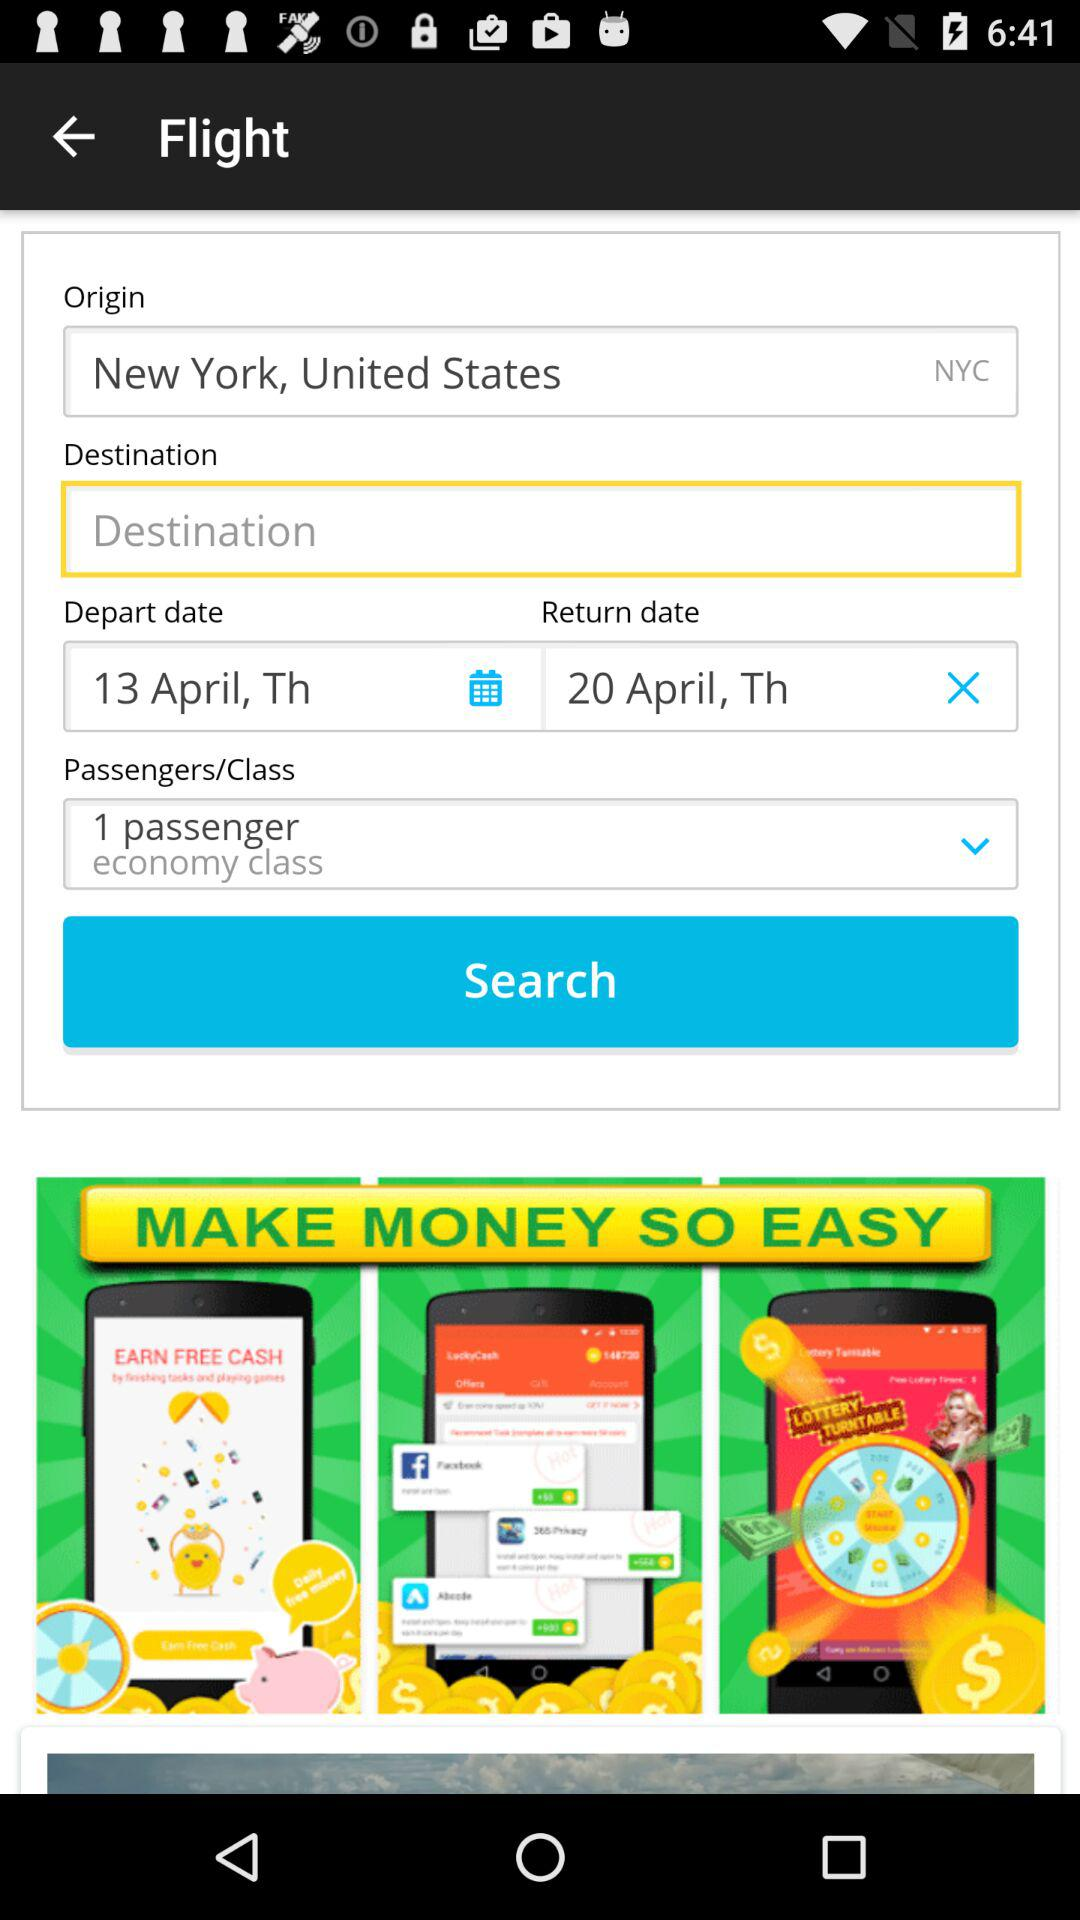How many passengers are in this flight search?
Answer the question using a single word or phrase. 1 